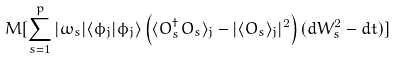Convert formula to latex. <formula><loc_0><loc_0><loc_500><loc_500>M [ \sum _ { s = 1 } ^ { p } | \omega _ { s } | \langle \phi _ { j } | \phi _ { j } \rangle \left ( \langle O _ { s } ^ { \dag } O _ { s } \rangle _ { j } - | \langle O _ { s } \rangle _ { j } | ^ { 2 } \right ) ( d W _ { s } ^ { 2 } - d t ) ]</formula> 